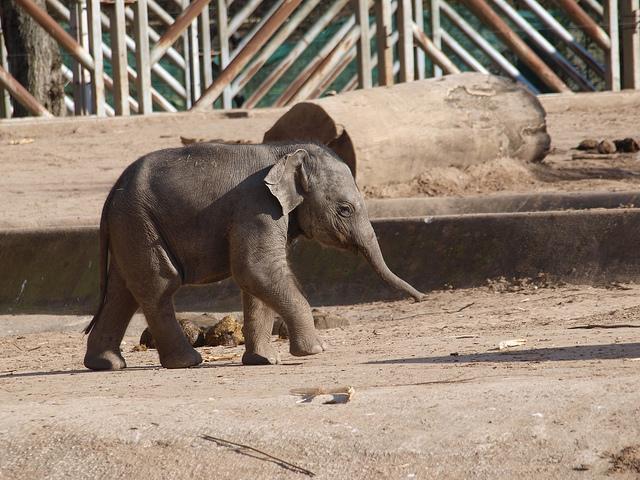How many orange cats are there in the image?
Give a very brief answer. 0. 